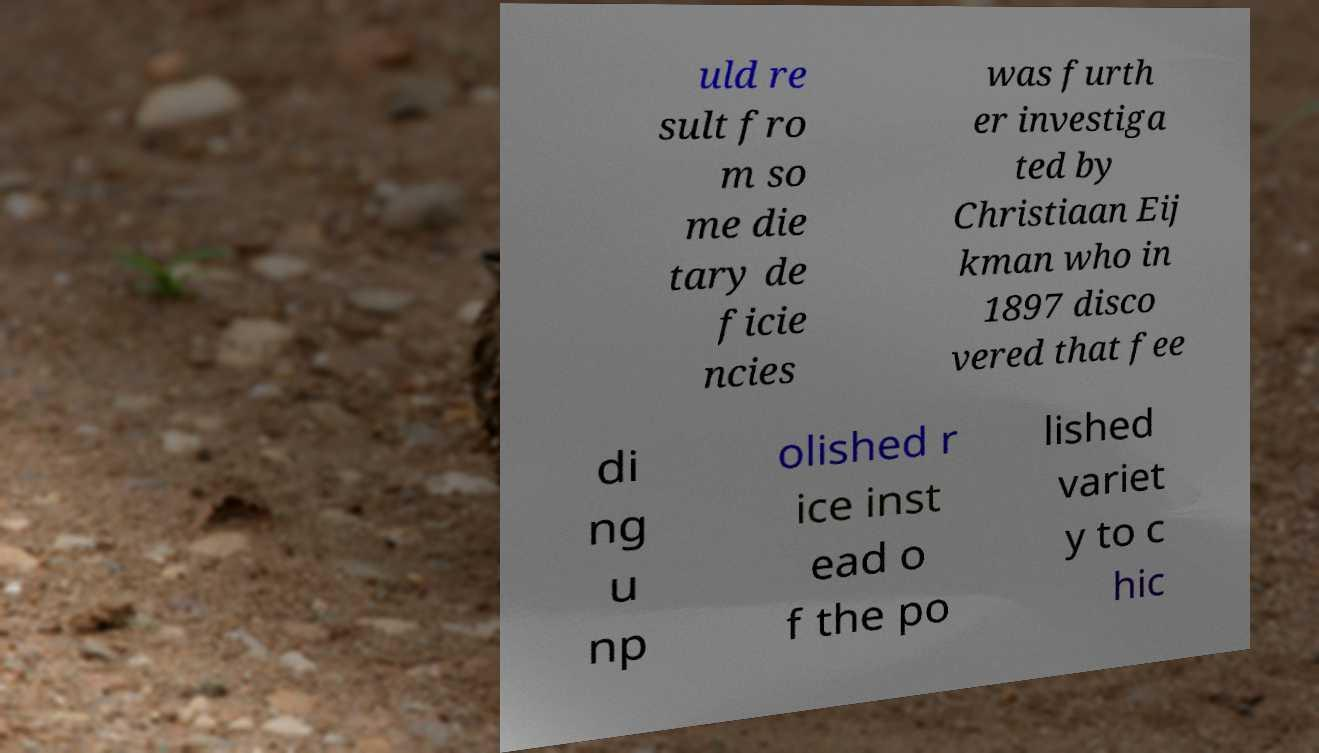I need the written content from this picture converted into text. Can you do that? uld re sult fro m so me die tary de ficie ncies was furth er investiga ted by Christiaan Eij kman who in 1897 disco vered that fee di ng u np olished r ice inst ead o f the po lished variet y to c hic 